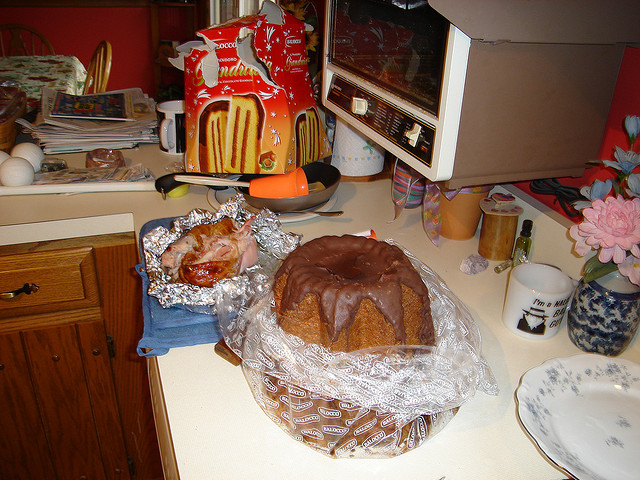<image>What is the name of this shop? There is no clear indication of the name of this shop. It could possibly be 'home kitchen'. Does that box of tofurkey have meat in it?? It is unanswerable whether the box of tofurkey has meat in it or not. What is the name of this shop? I don't know the name of this shop. It seems like there is no shop in the image. Does that box of tofurkey have meat in it?? It is unanswerable if the box of tofurkey has meat in it. It can be seen as both 'no' and 'no'. 